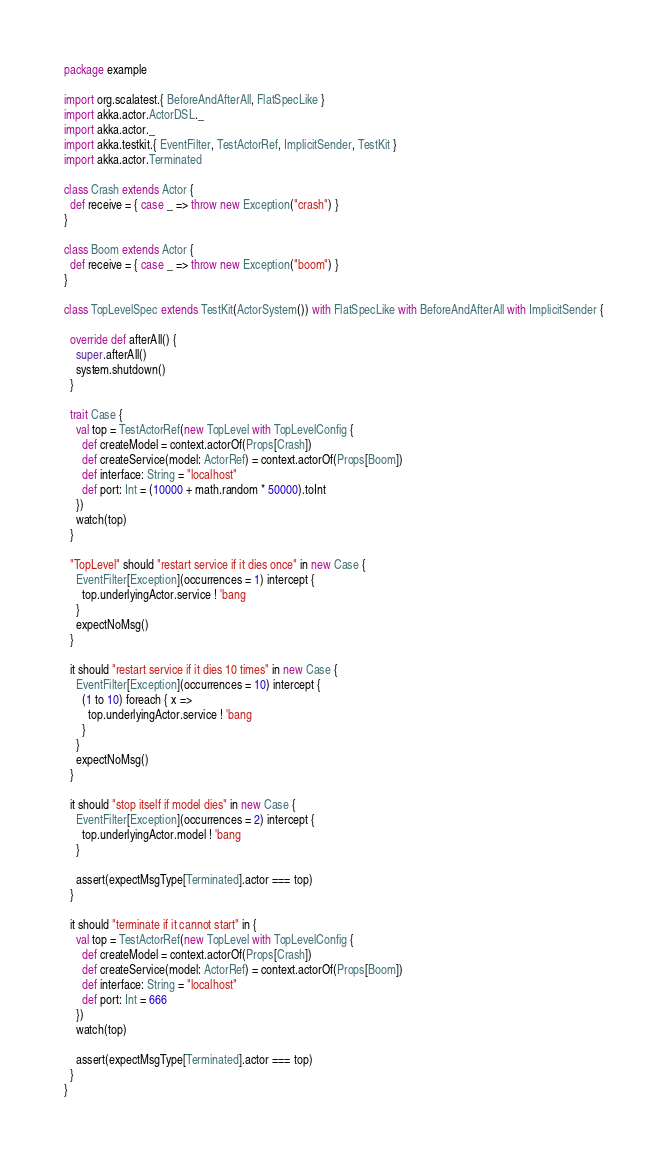Convert code to text. <code><loc_0><loc_0><loc_500><loc_500><_Scala_>package example

import org.scalatest.{ BeforeAndAfterAll, FlatSpecLike }
import akka.actor.ActorDSL._
import akka.actor._
import akka.testkit.{ EventFilter, TestActorRef, ImplicitSender, TestKit }
import akka.actor.Terminated

class Crash extends Actor {
  def receive = { case _ => throw new Exception("crash") }
}

class Boom extends Actor {
  def receive = { case _ => throw new Exception("boom") }
}

class TopLevelSpec extends TestKit(ActorSystem()) with FlatSpecLike with BeforeAndAfterAll with ImplicitSender {

  override def afterAll() {
    super.afterAll()
    system.shutdown()
  }

  trait Case {
    val top = TestActorRef(new TopLevel with TopLevelConfig {
      def createModel = context.actorOf(Props[Crash])
      def createService(model: ActorRef) = context.actorOf(Props[Boom])
      def interface: String = "localhost"
      def port: Int = (10000 + math.random * 50000).toInt
    })
    watch(top)
  }

  "TopLevel" should "restart service if it dies once" in new Case {
    EventFilter[Exception](occurrences = 1) intercept {
      top.underlyingActor.service ! 'bang
    }
    expectNoMsg()
  }

  it should "restart service if it dies 10 times" in new Case {
    EventFilter[Exception](occurrences = 10) intercept {
      (1 to 10) foreach { x =>
        top.underlyingActor.service ! 'bang
      }
    }
    expectNoMsg()
  }

  it should "stop itself if model dies" in new Case {
    EventFilter[Exception](occurrences = 2) intercept {
      top.underlyingActor.model ! 'bang
    }

    assert(expectMsgType[Terminated].actor === top)
  }

  it should "terminate if it cannot start" in {
    val top = TestActorRef(new TopLevel with TopLevelConfig {
      def createModel = context.actorOf(Props[Crash])
      def createService(model: ActorRef) = context.actorOf(Props[Boom])
      def interface: String = "localhost"
      def port: Int = 666
    })
    watch(top)

    assert(expectMsgType[Terminated].actor === top)
  }
}
</code> 